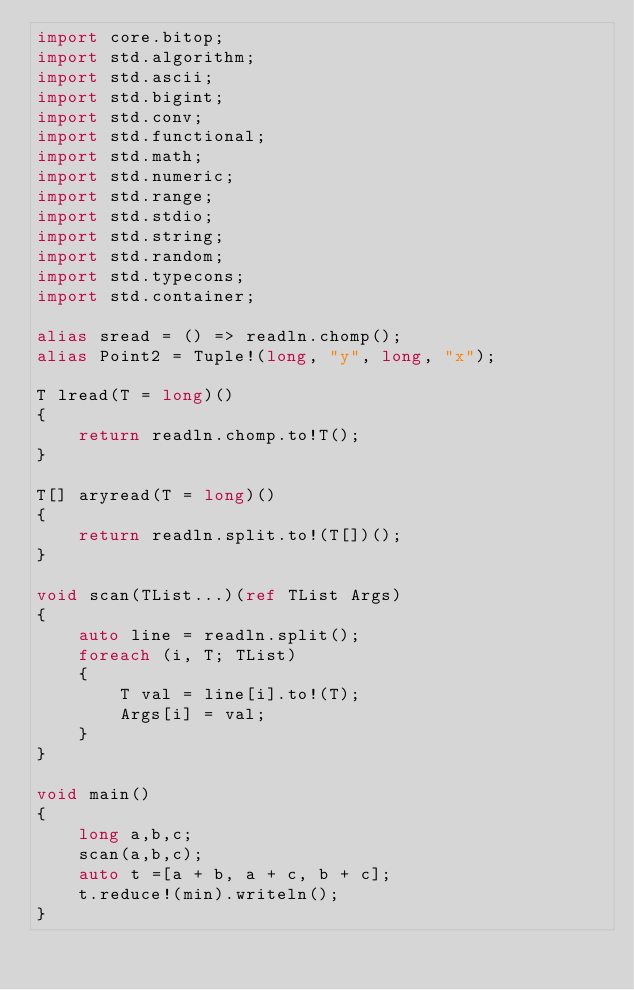Convert code to text. <code><loc_0><loc_0><loc_500><loc_500><_D_>import core.bitop;
import std.algorithm;
import std.ascii;
import std.bigint;
import std.conv;
import std.functional;
import std.math;
import std.numeric;
import std.range;
import std.stdio;
import std.string;
import std.random;
import std.typecons;
import std.container;

alias sread = () => readln.chomp();
alias Point2 = Tuple!(long, "y", long, "x");

T lread(T = long)()
{
    return readln.chomp.to!T();
}

T[] aryread(T = long)()
{
    return readln.split.to!(T[])();
}

void scan(TList...)(ref TList Args)
{
    auto line = readln.split();
    foreach (i, T; TList)
    {
        T val = line[i].to!(T);
        Args[i] = val;
    }
}

void main()
{
    long a,b,c;
    scan(a,b,c);
    auto t =[a + b, a + c, b + c];
    t.reduce!(min).writeln();
}</code> 